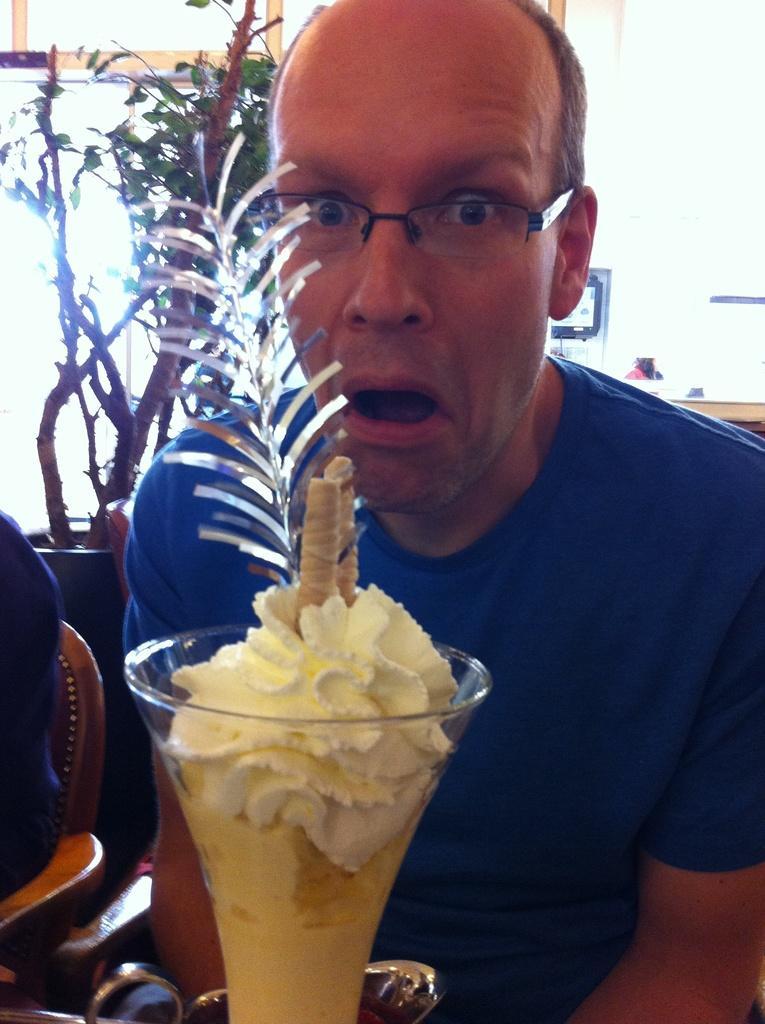In one or two sentences, can you explain what this image depicts? In this picture we can see a person, in front of him we can see a glass with ice cream and in the background we can see a house plant, frames, wall. 